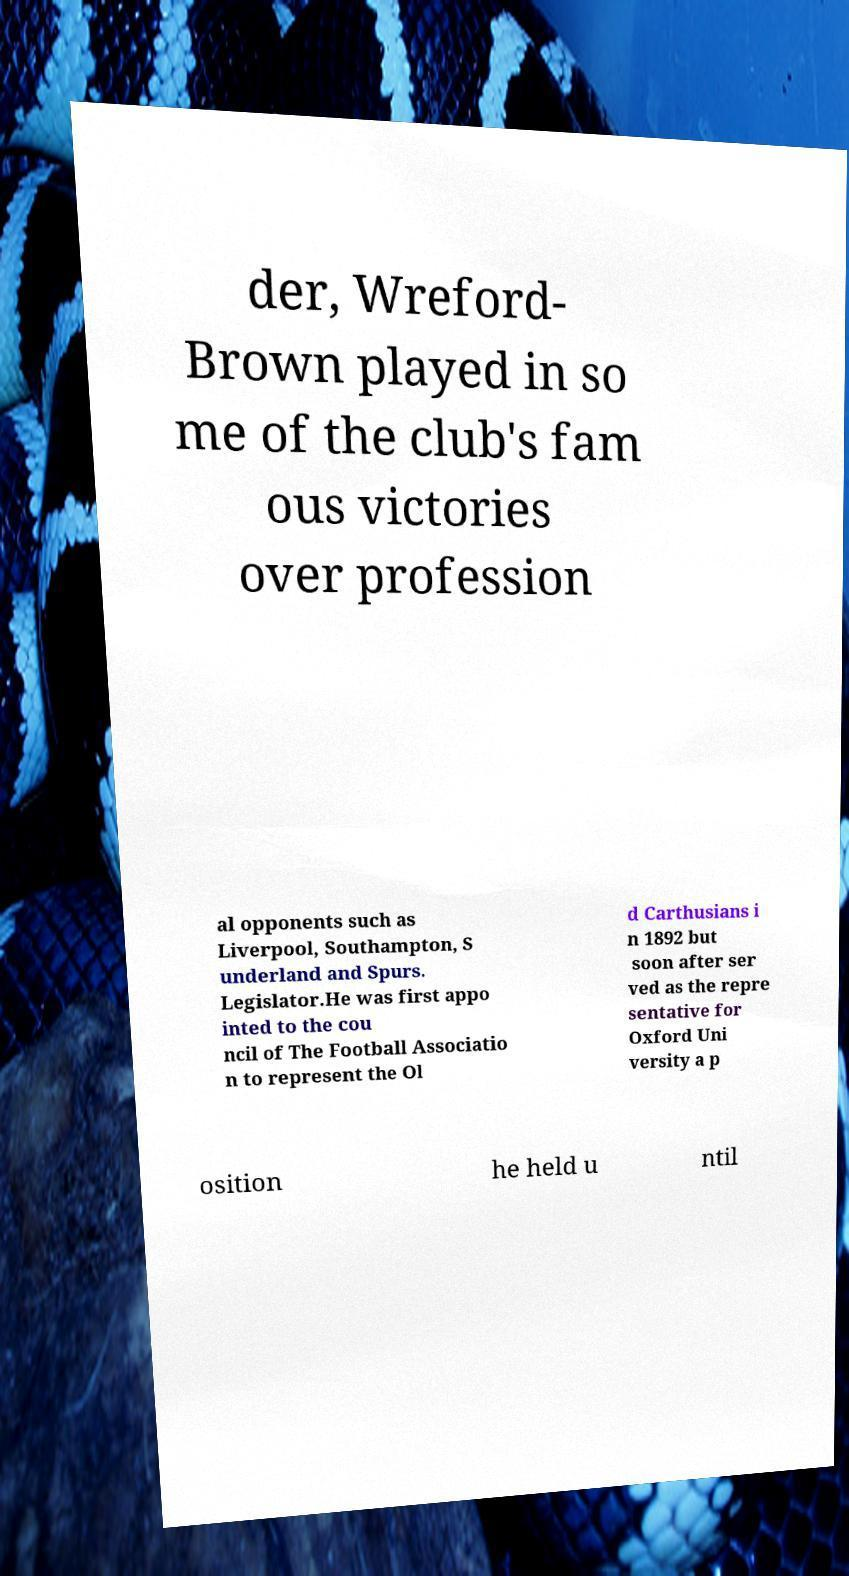Please identify and transcribe the text found in this image. der, Wreford- Brown played in so me of the club's fam ous victories over profession al opponents such as Liverpool, Southampton, S underland and Spurs. Legislator.He was first appo inted to the cou ncil of The Football Associatio n to represent the Ol d Carthusians i n 1892 but soon after ser ved as the repre sentative for Oxford Uni versity a p osition he held u ntil 